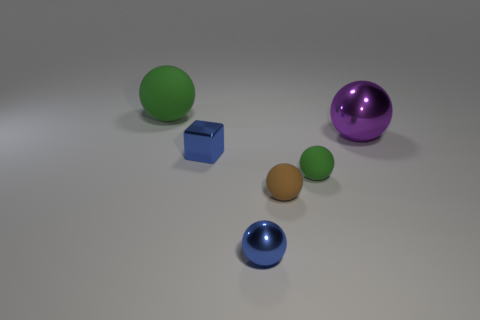Subtract all green balls. How many were subtracted if there are1green balls left? 1 Subtract all brown balls. How many balls are left? 4 Add 2 big purple shiny objects. How many objects exist? 8 Subtract all brown cylinders. How many green balls are left? 2 Subtract all blue balls. How many balls are left? 4 Subtract all spheres. How many objects are left? 1 Subtract all blue balls. Subtract all brown cylinders. How many balls are left? 4 Subtract all big spheres. Subtract all tiny brown matte things. How many objects are left? 3 Add 2 large purple shiny things. How many large purple shiny things are left? 3 Add 4 small brown matte spheres. How many small brown matte spheres exist? 5 